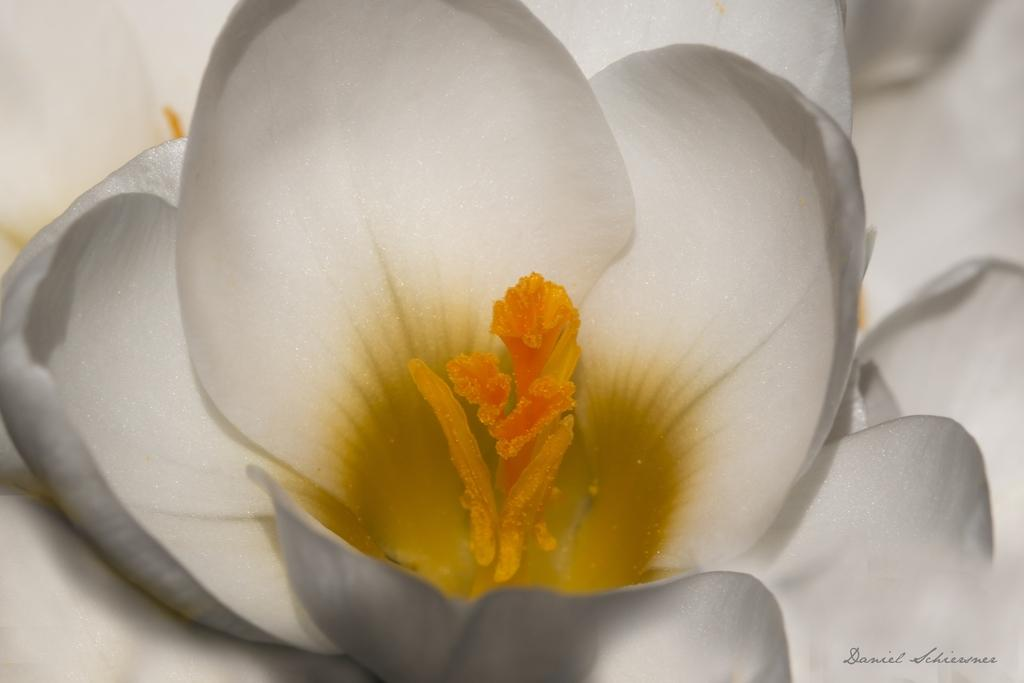What type of flowers can be seen in the image? There are white color flowers in the image. Is there any text or writing present in the image? Yes, there is text or writing on the bottom right of the image. Where is the playground located in the image? There is no playground present in the image. What type of vest is being worn by the flowers in the image? The flowers in the image do not wear vests, as they are inanimate objects. 